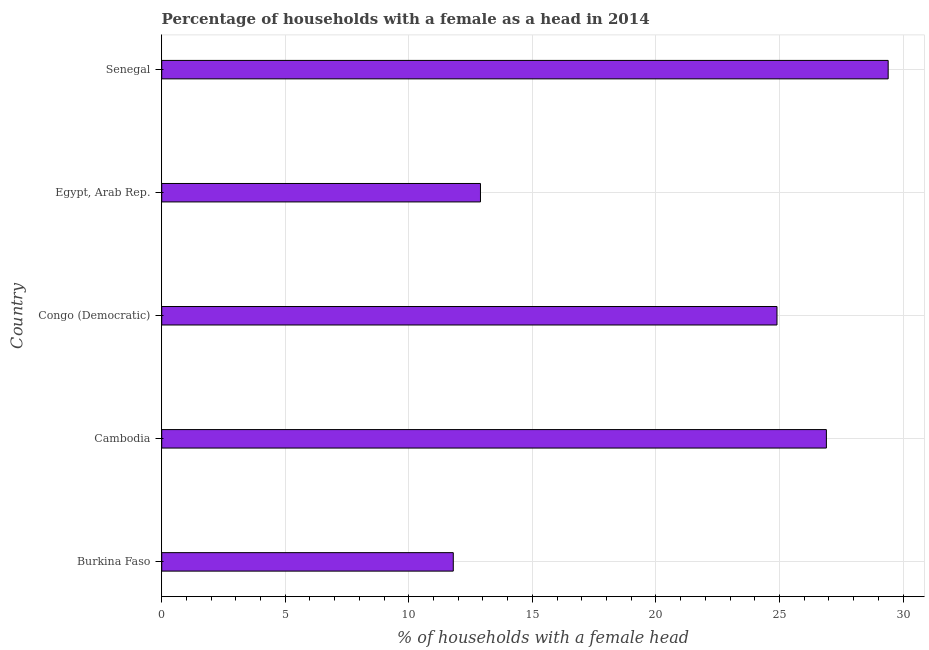What is the title of the graph?
Make the answer very short. Percentage of households with a female as a head in 2014. What is the label or title of the X-axis?
Give a very brief answer. % of households with a female head. What is the number of female supervised households in Senegal?
Keep it short and to the point. 29.4. Across all countries, what is the maximum number of female supervised households?
Give a very brief answer. 29.4. Across all countries, what is the minimum number of female supervised households?
Provide a succinct answer. 11.8. In which country was the number of female supervised households maximum?
Your response must be concise. Senegal. In which country was the number of female supervised households minimum?
Give a very brief answer. Burkina Faso. What is the sum of the number of female supervised households?
Your answer should be very brief. 105.9. What is the difference between the number of female supervised households in Burkina Faso and Senegal?
Offer a terse response. -17.6. What is the average number of female supervised households per country?
Your answer should be very brief. 21.18. What is the median number of female supervised households?
Provide a succinct answer. 24.9. Is the number of female supervised households in Congo (Democratic) less than that in Egypt, Arab Rep.?
Your answer should be very brief. No. What is the difference between the highest and the second highest number of female supervised households?
Your answer should be compact. 2.5. Is the sum of the number of female supervised households in Cambodia and Senegal greater than the maximum number of female supervised households across all countries?
Make the answer very short. Yes. What is the difference between the highest and the lowest number of female supervised households?
Ensure brevity in your answer.  17.6. In how many countries, is the number of female supervised households greater than the average number of female supervised households taken over all countries?
Keep it short and to the point. 3. Are all the bars in the graph horizontal?
Ensure brevity in your answer.  Yes. How many countries are there in the graph?
Provide a succinct answer. 5. What is the % of households with a female head of Cambodia?
Your response must be concise. 26.9. What is the % of households with a female head in Congo (Democratic)?
Ensure brevity in your answer.  24.9. What is the % of households with a female head in Senegal?
Offer a terse response. 29.4. What is the difference between the % of households with a female head in Burkina Faso and Cambodia?
Offer a terse response. -15.1. What is the difference between the % of households with a female head in Burkina Faso and Congo (Democratic)?
Keep it short and to the point. -13.1. What is the difference between the % of households with a female head in Burkina Faso and Egypt, Arab Rep.?
Offer a terse response. -1.1. What is the difference between the % of households with a female head in Burkina Faso and Senegal?
Your answer should be compact. -17.6. What is the difference between the % of households with a female head in Cambodia and Egypt, Arab Rep.?
Ensure brevity in your answer.  14. What is the difference between the % of households with a female head in Congo (Democratic) and Egypt, Arab Rep.?
Provide a short and direct response. 12. What is the difference between the % of households with a female head in Egypt, Arab Rep. and Senegal?
Your response must be concise. -16.5. What is the ratio of the % of households with a female head in Burkina Faso to that in Cambodia?
Your response must be concise. 0.44. What is the ratio of the % of households with a female head in Burkina Faso to that in Congo (Democratic)?
Give a very brief answer. 0.47. What is the ratio of the % of households with a female head in Burkina Faso to that in Egypt, Arab Rep.?
Provide a short and direct response. 0.92. What is the ratio of the % of households with a female head in Burkina Faso to that in Senegal?
Ensure brevity in your answer.  0.4. What is the ratio of the % of households with a female head in Cambodia to that in Egypt, Arab Rep.?
Ensure brevity in your answer.  2.08. What is the ratio of the % of households with a female head in Cambodia to that in Senegal?
Your answer should be very brief. 0.92. What is the ratio of the % of households with a female head in Congo (Democratic) to that in Egypt, Arab Rep.?
Keep it short and to the point. 1.93. What is the ratio of the % of households with a female head in Congo (Democratic) to that in Senegal?
Provide a short and direct response. 0.85. What is the ratio of the % of households with a female head in Egypt, Arab Rep. to that in Senegal?
Your answer should be very brief. 0.44. 